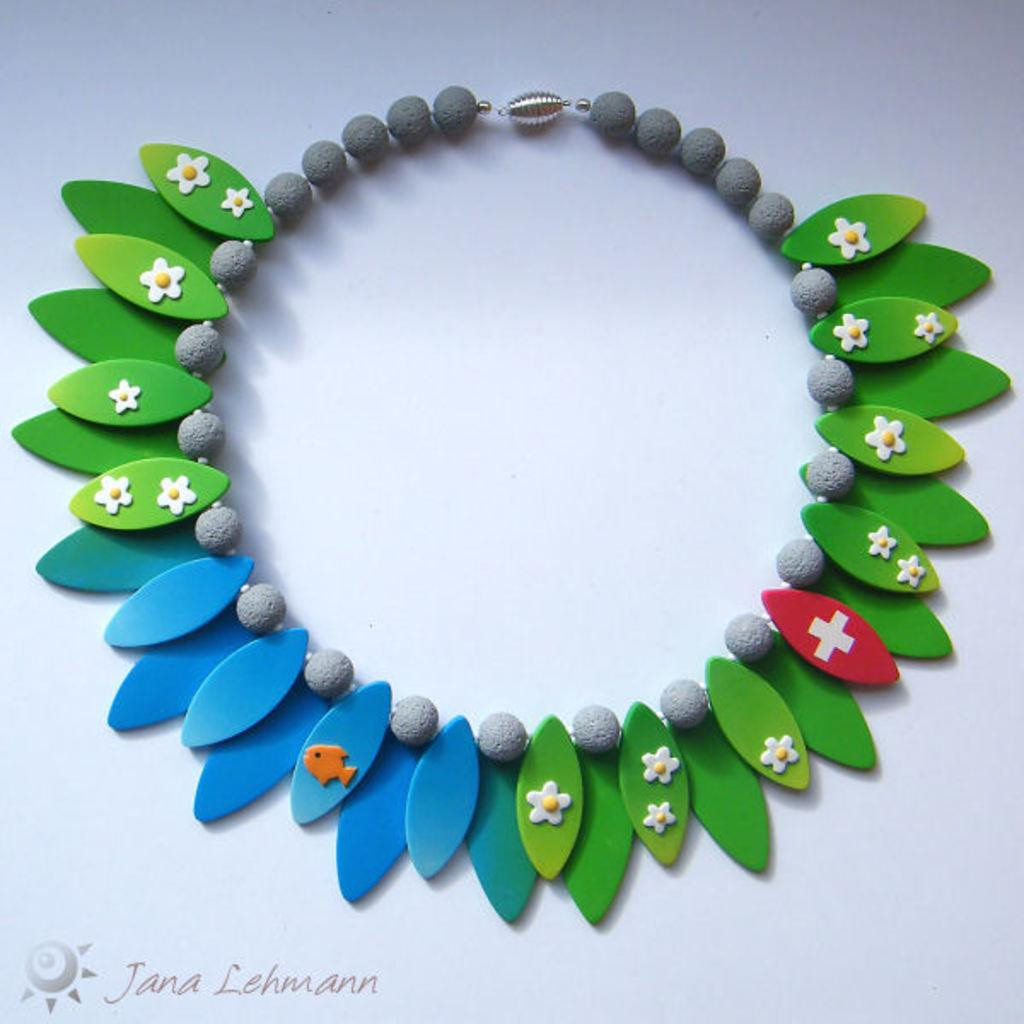What type of items are featured in the image? There is colorful jewelry in the image. What is the background or surface on which the jewelry is placed? The jewelry is on a grey color surface. What colors can be seen in the jewelry? The jewelry has colors including green, red, blue, orange, and white. What is the profit margin of the jewelry in the image? The image does not provide information about the profit margin of the jewelry, as it only shows the jewelry and its colors. 